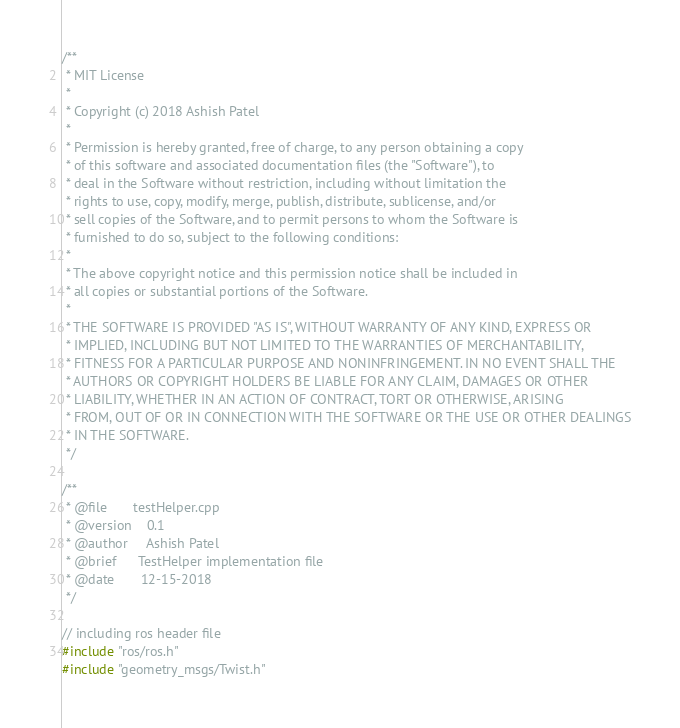Convert code to text. <code><loc_0><loc_0><loc_500><loc_500><_C++_>/**
 * MIT License
 *
 * Copyright (c) 2018 Ashish Patel
 *
 * Permission is hereby granted, free of charge, to any person obtaining a copy
 * of this software and associated documentation files (the "Software"), to 
 * deal in the Software without restriction, including without limitation the
 * rights to use, copy, modify, merge, publish, distribute, sublicense, and/or
 * sell copies of the Software, and to permit persons to whom the Software is
 * furnished to do so, subject to the following conditions:
 *
 * The above copyright notice and this permission notice shall be included in 
 * all copies or substantial portions of the Software.
 *
 * THE SOFTWARE IS PROVIDED "AS IS", WITHOUT WARRANTY OF ANY KIND, EXPRESS OR
 * IMPLIED, INCLUDING BUT NOT LIMITED TO THE WARRANTIES OF MERCHANTABILITY,
 * FITNESS FOR A PARTICULAR PURPOSE AND NONINFRINGEMENT. IN NO EVENT SHALL THE
 * AUTHORS OR COPYRIGHT HOLDERS BE LIABLE FOR ANY CLAIM, DAMAGES OR OTHER
 * LIABILITY, WHETHER IN AN ACTION OF CONTRACT, TORT OR OTHERWISE, ARISING 
 * FROM, OUT OF OR IN CONNECTION WITH THE SOFTWARE OR THE USE OR OTHER DEALINGS
 * IN THE SOFTWARE.
 */

/**
 * @file       testHelper.cpp
 * @version    0.1
 * @author     Ashish Patel
 * @brief      TestHelper implementation file
 * @date       12-15-2018
 */

// including ros header file
#include "ros/ros.h"
#include "geometry_msgs/Twist.h"
</code> 